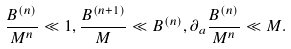<formula> <loc_0><loc_0><loc_500><loc_500>\frac { B ^ { ( n ) } } { M ^ { n } } \ll 1 , \frac { B ^ { ( n + 1 ) } } { M } \ll B ^ { ( n ) } , \partial _ { a } \frac { B ^ { ( n ) } } { M ^ { n } } \ll M .</formula> 